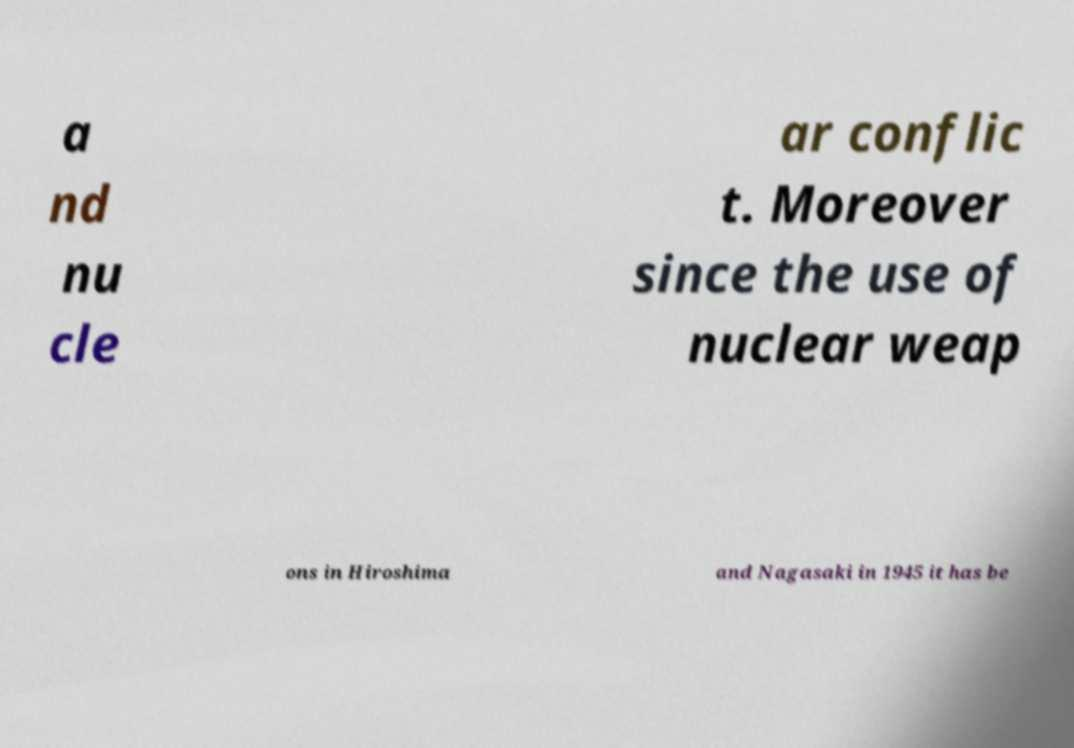Could you extract and type out the text from this image? a nd nu cle ar conflic t. Moreover since the use of nuclear weap ons in Hiroshima and Nagasaki in 1945 it has be 